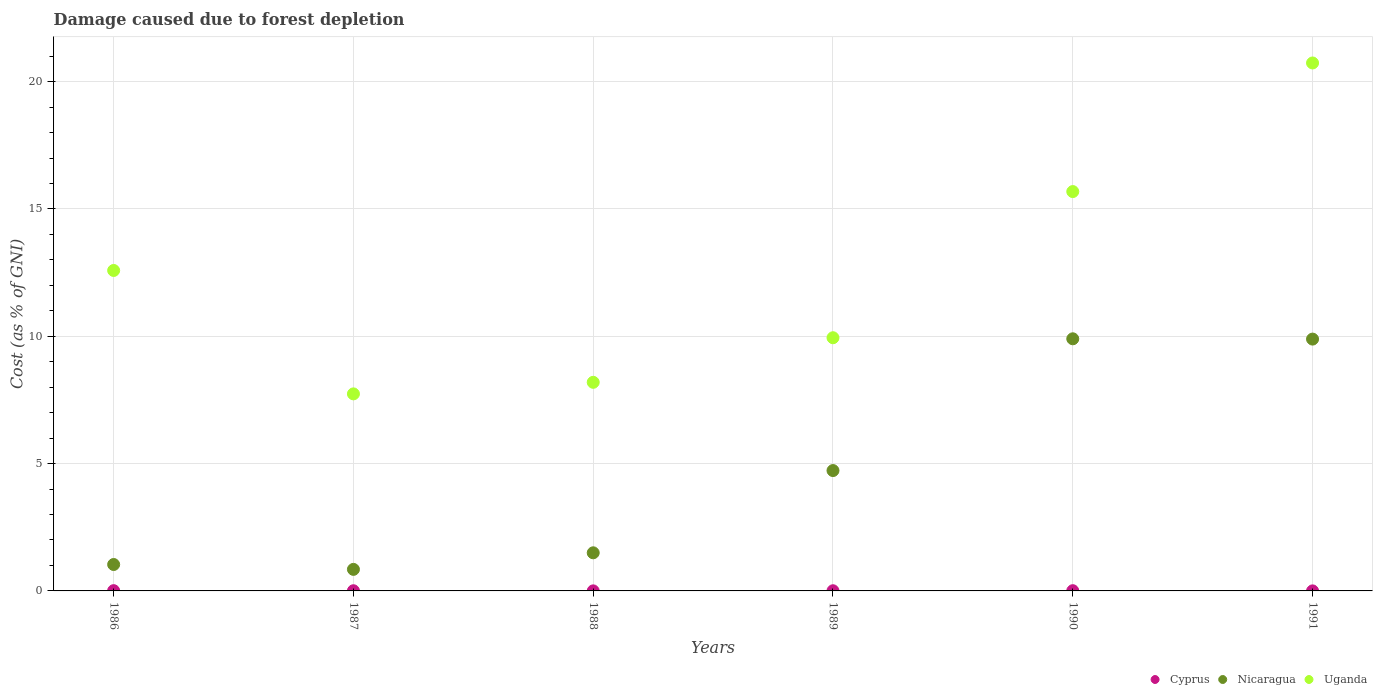What is the cost of damage caused due to forest depletion in Cyprus in 1987?
Ensure brevity in your answer.  0.01. Across all years, what is the maximum cost of damage caused due to forest depletion in Nicaragua?
Provide a short and direct response. 9.9. Across all years, what is the minimum cost of damage caused due to forest depletion in Cyprus?
Make the answer very short. 0. In which year was the cost of damage caused due to forest depletion in Cyprus maximum?
Your response must be concise. 1986. What is the total cost of damage caused due to forest depletion in Cyprus in the graph?
Give a very brief answer. 0.04. What is the difference between the cost of damage caused due to forest depletion in Uganda in 1988 and that in 1991?
Make the answer very short. -12.54. What is the difference between the cost of damage caused due to forest depletion in Nicaragua in 1988 and the cost of damage caused due to forest depletion in Uganda in 1990?
Make the answer very short. -14.19. What is the average cost of damage caused due to forest depletion in Uganda per year?
Provide a short and direct response. 12.48. In the year 1986, what is the difference between the cost of damage caused due to forest depletion in Cyprus and cost of damage caused due to forest depletion in Uganda?
Ensure brevity in your answer.  -12.57. What is the ratio of the cost of damage caused due to forest depletion in Cyprus in 1987 to that in 1988?
Your response must be concise. 3.62. Is the cost of damage caused due to forest depletion in Nicaragua in 1988 less than that in 1990?
Keep it short and to the point. Yes. What is the difference between the highest and the second highest cost of damage caused due to forest depletion in Cyprus?
Provide a short and direct response. 0. What is the difference between the highest and the lowest cost of damage caused due to forest depletion in Uganda?
Your response must be concise. 12.99. Is the sum of the cost of damage caused due to forest depletion in Nicaragua in 1986 and 1989 greater than the maximum cost of damage caused due to forest depletion in Uganda across all years?
Give a very brief answer. No. Is it the case that in every year, the sum of the cost of damage caused due to forest depletion in Uganda and cost of damage caused due to forest depletion in Cyprus  is greater than the cost of damage caused due to forest depletion in Nicaragua?
Your answer should be compact. Yes. Is the cost of damage caused due to forest depletion in Uganda strictly greater than the cost of damage caused due to forest depletion in Cyprus over the years?
Give a very brief answer. Yes. What is the difference between two consecutive major ticks on the Y-axis?
Provide a short and direct response. 5. Does the graph contain any zero values?
Provide a short and direct response. No. Where does the legend appear in the graph?
Ensure brevity in your answer.  Bottom right. How many legend labels are there?
Offer a very short reply. 3. How are the legend labels stacked?
Offer a terse response. Horizontal. What is the title of the graph?
Keep it short and to the point. Damage caused due to forest depletion. Does "Korea (Republic)" appear as one of the legend labels in the graph?
Your answer should be very brief. No. What is the label or title of the Y-axis?
Provide a short and direct response. Cost (as % of GNI). What is the Cost (as % of GNI) of Cyprus in 1986?
Make the answer very short. 0.01. What is the Cost (as % of GNI) in Nicaragua in 1986?
Give a very brief answer. 1.04. What is the Cost (as % of GNI) in Uganda in 1986?
Your answer should be very brief. 12.58. What is the Cost (as % of GNI) in Cyprus in 1987?
Your response must be concise. 0.01. What is the Cost (as % of GNI) in Nicaragua in 1987?
Your answer should be very brief. 0.85. What is the Cost (as % of GNI) of Uganda in 1987?
Your answer should be very brief. 7.74. What is the Cost (as % of GNI) in Cyprus in 1988?
Offer a terse response. 0. What is the Cost (as % of GNI) of Nicaragua in 1988?
Keep it short and to the point. 1.5. What is the Cost (as % of GNI) in Uganda in 1988?
Keep it short and to the point. 8.19. What is the Cost (as % of GNI) of Cyprus in 1989?
Offer a very short reply. 0.01. What is the Cost (as % of GNI) of Nicaragua in 1989?
Offer a terse response. 4.73. What is the Cost (as % of GNI) of Uganda in 1989?
Keep it short and to the point. 9.94. What is the Cost (as % of GNI) in Cyprus in 1990?
Offer a terse response. 0.01. What is the Cost (as % of GNI) of Nicaragua in 1990?
Your answer should be very brief. 9.9. What is the Cost (as % of GNI) of Uganda in 1990?
Ensure brevity in your answer.  15.68. What is the Cost (as % of GNI) of Cyprus in 1991?
Your answer should be very brief. 0. What is the Cost (as % of GNI) of Nicaragua in 1991?
Your response must be concise. 9.89. What is the Cost (as % of GNI) in Uganda in 1991?
Give a very brief answer. 20.73. Across all years, what is the maximum Cost (as % of GNI) of Cyprus?
Your answer should be very brief. 0.01. Across all years, what is the maximum Cost (as % of GNI) of Nicaragua?
Provide a short and direct response. 9.9. Across all years, what is the maximum Cost (as % of GNI) of Uganda?
Your answer should be very brief. 20.73. Across all years, what is the minimum Cost (as % of GNI) in Cyprus?
Offer a terse response. 0. Across all years, what is the minimum Cost (as % of GNI) of Nicaragua?
Ensure brevity in your answer.  0.85. Across all years, what is the minimum Cost (as % of GNI) of Uganda?
Offer a terse response. 7.74. What is the total Cost (as % of GNI) of Cyprus in the graph?
Keep it short and to the point. 0.04. What is the total Cost (as % of GNI) in Nicaragua in the graph?
Your answer should be very brief. 27.9. What is the total Cost (as % of GNI) of Uganda in the graph?
Your answer should be very brief. 74.87. What is the difference between the Cost (as % of GNI) of Cyprus in 1986 and that in 1987?
Keep it short and to the point. 0. What is the difference between the Cost (as % of GNI) in Nicaragua in 1986 and that in 1987?
Your answer should be compact. 0.19. What is the difference between the Cost (as % of GNI) of Uganda in 1986 and that in 1987?
Make the answer very short. 4.85. What is the difference between the Cost (as % of GNI) of Cyprus in 1986 and that in 1988?
Your answer should be compact. 0.01. What is the difference between the Cost (as % of GNI) of Nicaragua in 1986 and that in 1988?
Offer a terse response. -0.46. What is the difference between the Cost (as % of GNI) of Uganda in 1986 and that in 1988?
Provide a short and direct response. 4.39. What is the difference between the Cost (as % of GNI) of Cyprus in 1986 and that in 1989?
Ensure brevity in your answer.  0. What is the difference between the Cost (as % of GNI) of Nicaragua in 1986 and that in 1989?
Your answer should be very brief. -3.69. What is the difference between the Cost (as % of GNI) of Uganda in 1986 and that in 1989?
Your answer should be very brief. 2.64. What is the difference between the Cost (as % of GNI) in Cyprus in 1986 and that in 1990?
Your answer should be very brief. 0. What is the difference between the Cost (as % of GNI) of Nicaragua in 1986 and that in 1990?
Provide a short and direct response. -8.86. What is the difference between the Cost (as % of GNI) of Uganda in 1986 and that in 1990?
Offer a terse response. -3.1. What is the difference between the Cost (as % of GNI) of Cyprus in 1986 and that in 1991?
Your answer should be compact. 0.01. What is the difference between the Cost (as % of GNI) in Nicaragua in 1986 and that in 1991?
Provide a short and direct response. -8.85. What is the difference between the Cost (as % of GNI) of Uganda in 1986 and that in 1991?
Offer a very short reply. -8.15. What is the difference between the Cost (as % of GNI) in Cyprus in 1987 and that in 1988?
Provide a short and direct response. 0.01. What is the difference between the Cost (as % of GNI) in Nicaragua in 1987 and that in 1988?
Provide a short and direct response. -0.65. What is the difference between the Cost (as % of GNI) of Uganda in 1987 and that in 1988?
Give a very brief answer. -0.45. What is the difference between the Cost (as % of GNI) of Nicaragua in 1987 and that in 1989?
Your answer should be compact. -3.88. What is the difference between the Cost (as % of GNI) in Uganda in 1987 and that in 1989?
Your response must be concise. -2.2. What is the difference between the Cost (as % of GNI) in Cyprus in 1987 and that in 1990?
Ensure brevity in your answer.  -0. What is the difference between the Cost (as % of GNI) of Nicaragua in 1987 and that in 1990?
Ensure brevity in your answer.  -9.05. What is the difference between the Cost (as % of GNI) of Uganda in 1987 and that in 1990?
Make the answer very short. -7.94. What is the difference between the Cost (as % of GNI) in Cyprus in 1987 and that in 1991?
Keep it short and to the point. 0.01. What is the difference between the Cost (as % of GNI) in Nicaragua in 1987 and that in 1991?
Make the answer very short. -9.04. What is the difference between the Cost (as % of GNI) of Uganda in 1987 and that in 1991?
Your answer should be very brief. -12.99. What is the difference between the Cost (as % of GNI) of Cyprus in 1988 and that in 1989?
Provide a succinct answer. -0. What is the difference between the Cost (as % of GNI) in Nicaragua in 1988 and that in 1989?
Offer a very short reply. -3.23. What is the difference between the Cost (as % of GNI) in Uganda in 1988 and that in 1989?
Offer a terse response. -1.75. What is the difference between the Cost (as % of GNI) of Cyprus in 1988 and that in 1990?
Make the answer very short. -0.01. What is the difference between the Cost (as % of GNI) of Nicaragua in 1988 and that in 1990?
Your answer should be very brief. -8.4. What is the difference between the Cost (as % of GNI) in Uganda in 1988 and that in 1990?
Offer a terse response. -7.49. What is the difference between the Cost (as % of GNI) of Cyprus in 1988 and that in 1991?
Keep it short and to the point. 0. What is the difference between the Cost (as % of GNI) of Nicaragua in 1988 and that in 1991?
Provide a short and direct response. -8.39. What is the difference between the Cost (as % of GNI) of Uganda in 1988 and that in 1991?
Keep it short and to the point. -12.54. What is the difference between the Cost (as % of GNI) of Cyprus in 1989 and that in 1990?
Provide a short and direct response. -0. What is the difference between the Cost (as % of GNI) in Nicaragua in 1989 and that in 1990?
Provide a short and direct response. -5.17. What is the difference between the Cost (as % of GNI) of Uganda in 1989 and that in 1990?
Keep it short and to the point. -5.74. What is the difference between the Cost (as % of GNI) of Cyprus in 1989 and that in 1991?
Your answer should be compact. 0. What is the difference between the Cost (as % of GNI) of Nicaragua in 1989 and that in 1991?
Provide a succinct answer. -5.16. What is the difference between the Cost (as % of GNI) of Uganda in 1989 and that in 1991?
Your answer should be compact. -10.79. What is the difference between the Cost (as % of GNI) of Cyprus in 1990 and that in 1991?
Keep it short and to the point. 0.01. What is the difference between the Cost (as % of GNI) in Nicaragua in 1990 and that in 1991?
Make the answer very short. 0.01. What is the difference between the Cost (as % of GNI) of Uganda in 1990 and that in 1991?
Ensure brevity in your answer.  -5.05. What is the difference between the Cost (as % of GNI) of Cyprus in 1986 and the Cost (as % of GNI) of Nicaragua in 1987?
Make the answer very short. -0.84. What is the difference between the Cost (as % of GNI) of Cyprus in 1986 and the Cost (as % of GNI) of Uganda in 1987?
Make the answer very short. -7.73. What is the difference between the Cost (as % of GNI) of Nicaragua in 1986 and the Cost (as % of GNI) of Uganda in 1987?
Make the answer very short. -6.7. What is the difference between the Cost (as % of GNI) of Cyprus in 1986 and the Cost (as % of GNI) of Nicaragua in 1988?
Keep it short and to the point. -1.49. What is the difference between the Cost (as % of GNI) in Cyprus in 1986 and the Cost (as % of GNI) in Uganda in 1988?
Your answer should be compact. -8.18. What is the difference between the Cost (as % of GNI) in Nicaragua in 1986 and the Cost (as % of GNI) in Uganda in 1988?
Make the answer very short. -7.15. What is the difference between the Cost (as % of GNI) in Cyprus in 1986 and the Cost (as % of GNI) in Nicaragua in 1989?
Keep it short and to the point. -4.72. What is the difference between the Cost (as % of GNI) of Cyprus in 1986 and the Cost (as % of GNI) of Uganda in 1989?
Your response must be concise. -9.93. What is the difference between the Cost (as % of GNI) of Nicaragua in 1986 and the Cost (as % of GNI) of Uganda in 1989?
Offer a terse response. -8.91. What is the difference between the Cost (as % of GNI) in Cyprus in 1986 and the Cost (as % of GNI) in Nicaragua in 1990?
Offer a very short reply. -9.89. What is the difference between the Cost (as % of GNI) in Cyprus in 1986 and the Cost (as % of GNI) in Uganda in 1990?
Ensure brevity in your answer.  -15.67. What is the difference between the Cost (as % of GNI) in Nicaragua in 1986 and the Cost (as % of GNI) in Uganda in 1990?
Keep it short and to the point. -14.64. What is the difference between the Cost (as % of GNI) of Cyprus in 1986 and the Cost (as % of GNI) of Nicaragua in 1991?
Make the answer very short. -9.88. What is the difference between the Cost (as % of GNI) in Cyprus in 1986 and the Cost (as % of GNI) in Uganda in 1991?
Ensure brevity in your answer.  -20.72. What is the difference between the Cost (as % of GNI) of Nicaragua in 1986 and the Cost (as % of GNI) of Uganda in 1991?
Provide a short and direct response. -19.7. What is the difference between the Cost (as % of GNI) of Cyprus in 1987 and the Cost (as % of GNI) of Nicaragua in 1988?
Give a very brief answer. -1.49. What is the difference between the Cost (as % of GNI) in Cyprus in 1987 and the Cost (as % of GNI) in Uganda in 1988?
Provide a short and direct response. -8.18. What is the difference between the Cost (as % of GNI) in Nicaragua in 1987 and the Cost (as % of GNI) in Uganda in 1988?
Keep it short and to the point. -7.35. What is the difference between the Cost (as % of GNI) in Cyprus in 1987 and the Cost (as % of GNI) in Nicaragua in 1989?
Your answer should be very brief. -4.72. What is the difference between the Cost (as % of GNI) of Cyprus in 1987 and the Cost (as % of GNI) of Uganda in 1989?
Provide a short and direct response. -9.94. What is the difference between the Cost (as % of GNI) of Nicaragua in 1987 and the Cost (as % of GNI) of Uganda in 1989?
Keep it short and to the point. -9.1. What is the difference between the Cost (as % of GNI) in Cyprus in 1987 and the Cost (as % of GNI) in Nicaragua in 1990?
Provide a short and direct response. -9.89. What is the difference between the Cost (as % of GNI) in Cyprus in 1987 and the Cost (as % of GNI) in Uganda in 1990?
Provide a short and direct response. -15.68. What is the difference between the Cost (as % of GNI) of Nicaragua in 1987 and the Cost (as % of GNI) of Uganda in 1990?
Keep it short and to the point. -14.84. What is the difference between the Cost (as % of GNI) of Cyprus in 1987 and the Cost (as % of GNI) of Nicaragua in 1991?
Your answer should be compact. -9.88. What is the difference between the Cost (as % of GNI) of Cyprus in 1987 and the Cost (as % of GNI) of Uganda in 1991?
Your response must be concise. -20.73. What is the difference between the Cost (as % of GNI) of Nicaragua in 1987 and the Cost (as % of GNI) of Uganda in 1991?
Give a very brief answer. -19.89. What is the difference between the Cost (as % of GNI) in Cyprus in 1988 and the Cost (as % of GNI) in Nicaragua in 1989?
Your response must be concise. -4.72. What is the difference between the Cost (as % of GNI) of Cyprus in 1988 and the Cost (as % of GNI) of Uganda in 1989?
Your answer should be very brief. -9.94. What is the difference between the Cost (as % of GNI) of Nicaragua in 1988 and the Cost (as % of GNI) of Uganda in 1989?
Ensure brevity in your answer.  -8.45. What is the difference between the Cost (as % of GNI) of Cyprus in 1988 and the Cost (as % of GNI) of Nicaragua in 1990?
Keep it short and to the point. -9.9. What is the difference between the Cost (as % of GNI) of Cyprus in 1988 and the Cost (as % of GNI) of Uganda in 1990?
Your response must be concise. -15.68. What is the difference between the Cost (as % of GNI) of Nicaragua in 1988 and the Cost (as % of GNI) of Uganda in 1990?
Give a very brief answer. -14.19. What is the difference between the Cost (as % of GNI) in Cyprus in 1988 and the Cost (as % of GNI) in Nicaragua in 1991?
Your answer should be compact. -9.89. What is the difference between the Cost (as % of GNI) of Cyprus in 1988 and the Cost (as % of GNI) of Uganda in 1991?
Offer a terse response. -20.73. What is the difference between the Cost (as % of GNI) in Nicaragua in 1988 and the Cost (as % of GNI) in Uganda in 1991?
Offer a terse response. -19.24. What is the difference between the Cost (as % of GNI) in Cyprus in 1989 and the Cost (as % of GNI) in Nicaragua in 1990?
Keep it short and to the point. -9.89. What is the difference between the Cost (as % of GNI) of Cyprus in 1989 and the Cost (as % of GNI) of Uganda in 1990?
Keep it short and to the point. -15.68. What is the difference between the Cost (as % of GNI) of Nicaragua in 1989 and the Cost (as % of GNI) of Uganda in 1990?
Keep it short and to the point. -10.96. What is the difference between the Cost (as % of GNI) in Cyprus in 1989 and the Cost (as % of GNI) in Nicaragua in 1991?
Make the answer very short. -9.88. What is the difference between the Cost (as % of GNI) of Cyprus in 1989 and the Cost (as % of GNI) of Uganda in 1991?
Offer a very short reply. -20.73. What is the difference between the Cost (as % of GNI) of Nicaragua in 1989 and the Cost (as % of GNI) of Uganda in 1991?
Offer a very short reply. -16.01. What is the difference between the Cost (as % of GNI) of Cyprus in 1990 and the Cost (as % of GNI) of Nicaragua in 1991?
Provide a succinct answer. -9.88. What is the difference between the Cost (as % of GNI) of Cyprus in 1990 and the Cost (as % of GNI) of Uganda in 1991?
Your answer should be very brief. -20.72. What is the difference between the Cost (as % of GNI) of Nicaragua in 1990 and the Cost (as % of GNI) of Uganda in 1991?
Your answer should be compact. -10.83. What is the average Cost (as % of GNI) of Cyprus per year?
Keep it short and to the point. 0.01. What is the average Cost (as % of GNI) in Nicaragua per year?
Offer a terse response. 4.65. What is the average Cost (as % of GNI) of Uganda per year?
Offer a terse response. 12.48. In the year 1986, what is the difference between the Cost (as % of GNI) in Cyprus and Cost (as % of GNI) in Nicaragua?
Provide a short and direct response. -1.03. In the year 1986, what is the difference between the Cost (as % of GNI) in Cyprus and Cost (as % of GNI) in Uganda?
Provide a succinct answer. -12.57. In the year 1986, what is the difference between the Cost (as % of GNI) in Nicaragua and Cost (as % of GNI) in Uganda?
Ensure brevity in your answer.  -11.55. In the year 1987, what is the difference between the Cost (as % of GNI) of Cyprus and Cost (as % of GNI) of Nicaragua?
Offer a terse response. -0.84. In the year 1987, what is the difference between the Cost (as % of GNI) of Cyprus and Cost (as % of GNI) of Uganda?
Keep it short and to the point. -7.73. In the year 1987, what is the difference between the Cost (as % of GNI) of Nicaragua and Cost (as % of GNI) of Uganda?
Keep it short and to the point. -6.89. In the year 1988, what is the difference between the Cost (as % of GNI) of Cyprus and Cost (as % of GNI) of Nicaragua?
Keep it short and to the point. -1.49. In the year 1988, what is the difference between the Cost (as % of GNI) of Cyprus and Cost (as % of GNI) of Uganda?
Your answer should be very brief. -8.19. In the year 1988, what is the difference between the Cost (as % of GNI) of Nicaragua and Cost (as % of GNI) of Uganda?
Your answer should be compact. -6.7. In the year 1989, what is the difference between the Cost (as % of GNI) of Cyprus and Cost (as % of GNI) of Nicaragua?
Make the answer very short. -4.72. In the year 1989, what is the difference between the Cost (as % of GNI) of Cyprus and Cost (as % of GNI) of Uganda?
Provide a short and direct response. -9.94. In the year 1989, what is the difference between the Cost (as % of GNI) of Nicaragua and Cost (as % of GNI) of Uganda?
Your answer should be very brief. -5.22. In the year 1990, what is the difference between the Cost (as % of GNI) in Cyprus and Cost (as % of GNI) in Nicaragua?
Offer a very short reply. -9.89. In the year 1990, what is the difference between the Cost (as % of GNI) of Cyprus and Cost (as % of GNI) of Uganda?
Make the answer very short. -15.67. In the year 1990, what is the difference between the Cost (as % of GNI) of Nicaragua and Cost (as % of GNI) of Uganda?
Give a very brief answer. -5.78. In the year 1991, what is the difference between the Cost (as % of GNI) of Cyprus and Cost (as % of GNI) of Nicaragua?
Keep it short and to the point. -9.89. In the year 1991, what is the difference between the Cost (as % of GNI) of Cyprus and Cost (as % of GNI) of Uganda?
Provide a short and direct response. -20.73. In the year 1991, what is the difference between the Cost (as % of GNI) of Nicaragua and Cost (as % of GNI) of Uganda?
Provide a succinct answer. -10.84. What is the ratio of the Cost (as % of GNI) of Cyprus in 1986 to that in 1987?
Ensure brevity in your answer.  1.43. What is the ratio of the Cost (as % of GNI) of Nicaragua in 1986 to that in 1987?
Your answer should be very brief. 1.23. What is the ratio of the Cost (as % of GNI) in Uganda in 1986 to that in 1987?
Your answer should be very brief. 1.63. What is the ratio of the Cost (as % of GNI) in Cyprus in 1986 to that in 1988?
Your answer should be compact. 5.17. What is the ratio of the Cost (as % of GNI) in Nicaragua in 1986 to that in 1988?
Offer a very short reply. 0.69. What is the ratio of the Cost (as % of GNI) of Uganda in 1986 to that in 1988?
Your response must be concise. 1.54. What is the ratio of the Cost (as % of GNI) in Cyprus in 1986 to that in 1989?
Your answer should be compact. 1.52. What is the ratio of the Cost (as % of GNI) in Nicaragua in 1986 to that in 1989?
Your response must be concise. 0.22. What is the ratio of the Cost (as % of GNI) of Uganda in 1986 to that in 1989?
Offer a terse response. 1.27. What is the ratio of the Cost (as % of GNI) of Cyprus in 1986 to that in 1990?
Keep it short and to the point. 1.12. What is the ratio of the Cost (as % of GNI) of Nicaragua in 1986 to that in 1990?
Your answer should be compact. 0.1. What is the ratio of the Cost (as % of GNI) of Uganda in 1986 to that in 1990?
Your answer should be compact. 0.8. What is the ratio of the Cost (as % of GNI) in Cyprus in 1986 to that in 1991?
Ensure brevity in your answer.  5.78. What is the ratio of the Cost (as % of GNI) in Nicaragua in 1986 to that in 1991?
Your response must be concise. 0.1. What is the ratio of the Cost (as % of GNI) in Uganda in 1986 to that in 1991?
Provide a succinct answer. 0.61. What is the ratio of the Cost (as % of GNI) in Cyprus in 1987 to that in 1988?
Your answer should be very brief. 3.62. What is the ratio of the Cost (as % of GNI) in Nicaragua in 1987 to that in 1988?
Provide a short and direct response. 0.57. What is the ratio of the Cost (as % of GNI) in Uganda in 1987 to that in 1988?
Give a very brief answer. 0.94. What is the ratio of the Cost (as % of GNI) in Cyprus in 1987 to that in 1989?
Your answer should be very brief. 1.06. What is the ratio of the Cost (as % of GNI) of Nicaragua in 1987 to that in 1989?
Provide a succinct answer. 0.18. What is the ratio of the Cost (as % of GNI) of Uganda in 1987 to that in 1989?
Ensure brevity in your answer.  0.78. What is the ratio of the Cost (as % of GNI) in Cyprus in 1987 to that in 1990?
Your response must be concise. 0.78. What is the ratio of the Cost (as % of GNI) of Nicaragua in 1987 to that in 1990?
Provide a short and direct response. 0.09. What is the ratio of the Cost (as % of GNI) of Uganda in 1987 to that in 1990?
Your answer should be very brief. 0.49. What is the ratio of the Cost (as % of GNI) of Cyprus in 1987 to that in 1991?
Give a very brief answer. 4.05. What is the ratio of the Cost (as % of GNI) of Nicaragua in 1987 to that in 1991?
Offer a terse response. 0.09. What is the ratio of the Cost (as % of GNI) of Uganda in 1987 to that in 1991?
Your answer should be very brief. 0.37. What is the ratio of the Cost (as % of GNI) in Cyprus in 1988 to that in 1989?
Provide a short and direct response. 0.29. What is the ratio of the Cost (as % of GNI) of Nicaragua in 1988 to that in 1989?
Give a very brief answer. 0.32. What is the ratio of the Cost (as % of GNI) in Uganda in 1988 to that in 1989?
Your answer should be compact. 0.82. What is the ratio of the Cost (as % of GNI) of Cyprus in 1988 to that in 1990?
Your answer should be very brief. 0.22. What is the ratio of the Cost (as % of GNI) of Nicaragua in 1988 to that in 1990?
Offer a terse response. 0.15. What is the ratio of the Cost (as % of GNI) of Uganda in 1988 to that in 1990?
Your answer should be compact. 0.52. What is the ratio of the Cost (as % of GNI) in Cyprus in 1988 to that in 1991?
Offer a terse response. 1.12. What is the ratio of the Cost (as % of GNI) in Nicaragua in 1988 to that in 1991?
Make the answer very short. 0.15. What is the ratio of the Cost (as % of GNI) of Uganda in 1988 to that in 1991?
Provide a short and direct response. 0.4. What is the ratio of the Cost (as % of GNI) in Cyprus in 1989 to that in 1990?
Offer a terse response. 0.74. What is the ratio of the Cost (as % of GNI) of Nicaragua in 1989 to that in 1990?
Your answer should be very brief. 0.48. What is the ratio of the Cost (as % of GNI) of Uganda in 1989 to that in 1990?
Your answer should be very brief. 0.63. What is the ratio of the Cost (as % of GNI) of Cyprus in 1989 to that in 1991?
Keep it short and to the point. 3.81. What is the ratio of the Cost (as % of GNI) of Nicaragua in 1989 to that in 1991?
Offer a very short reply. 0.48. What is the ratio of the Cost (as % of GNI) of Uganda in 1989 to that in 1991?
Provide a short and direct response. 0.48. What is the ratio of the Cost (as % of GNI) in Cyprus in 1990 to that in 1991?
Give a very brief answer. 5.17. What is the ratio of the Cost (as % of GNI) of Nicaragua in 1990 to that in 1991?
Provide a succinct answer. 1. What is the ratio of the Cost (as % of GNI) in Uganda in 1990 to that in 1991?
Offer a terse response. 0.76. What is the difference between the highest and the second highest Cost (as % of GNI) in Cyprus?
Your answer should be compact. 0. What is the difference between the highest and the second highest Cost (as % of GNI) in Nicaragua?
Make the answer very short. 0.01. What is the difference between the highest and the second highest Cost (as % of GNI) in Uganda?
Offer a terse response. 5.05. What is the difference between the highest and the lowest Cost (as % of GNI) of Cyprus?
Make the answer very short. 0.01. What is the difference between the highest and the lowest Cost (as % of GNI) of Nicaragua?
Give a very brief answer. 9.05. What is the difference between the highest and the lowest Cost (as % of GNI) of Uganda?
Make the answer very short. 12.99. 